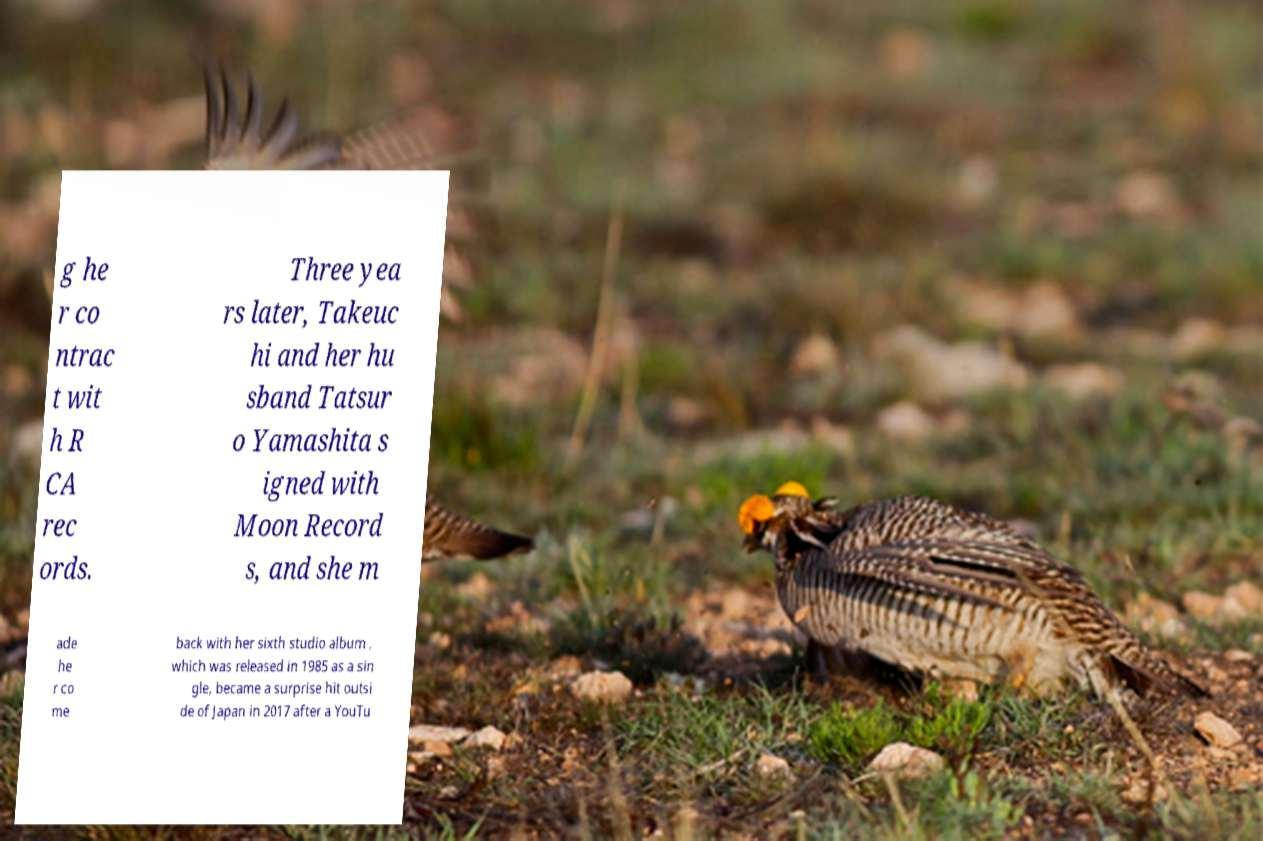Could you extract and type out the text from this image? g he r co ntrac t wit h R CA rec ords. Three yea rs later, Takeuc hi and her hu sband Tatsur o Yamashita s igned with Moon Record s, and she m ade he r co me back with her sixth studio album , which was released in 1985 as a sin gle, became a surprise hit outsi de of Japan in 2017 after a YouTu 